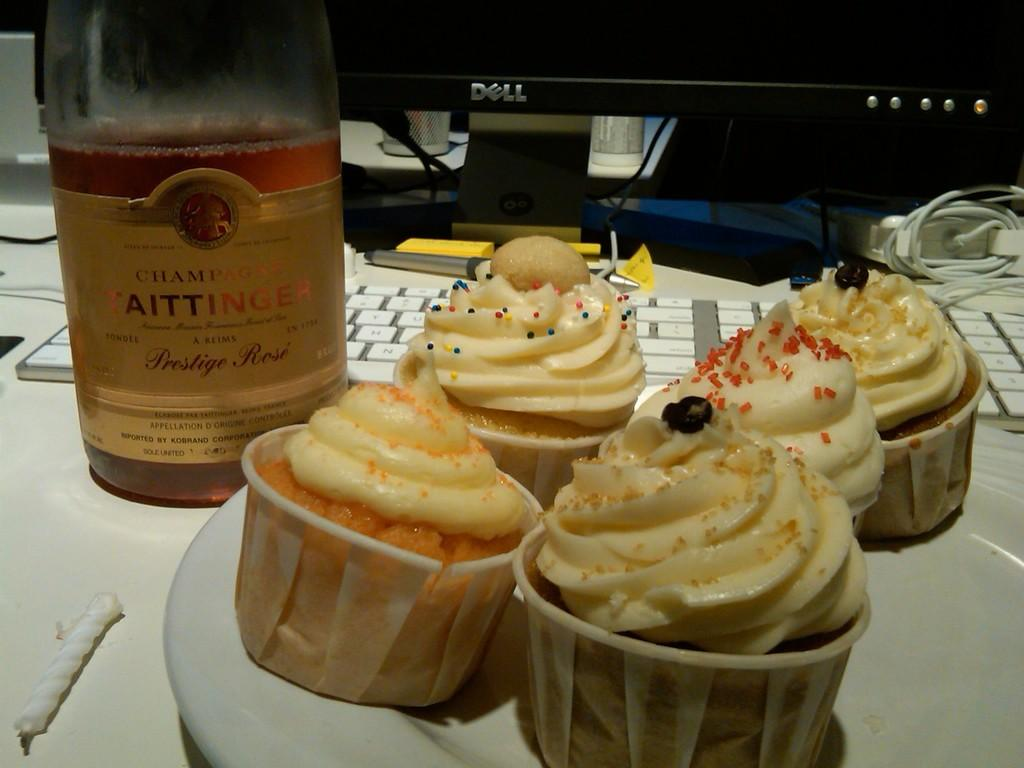What type of food is on the plate in the image? There are cupcakes on the plate in the image. What is the other beverage-related object in the image? There is a bottle in the image. What electronic devices are present in the image? There is a keyboard and a desktop computer in the image. Where are all these objects located? All these objects are on a table. What is the value of the cupcakes in the image? The value of the cupcakes cannot be determined from the image alone. What time of day is depicted in the image? The image does not provide any information about the time of day. 